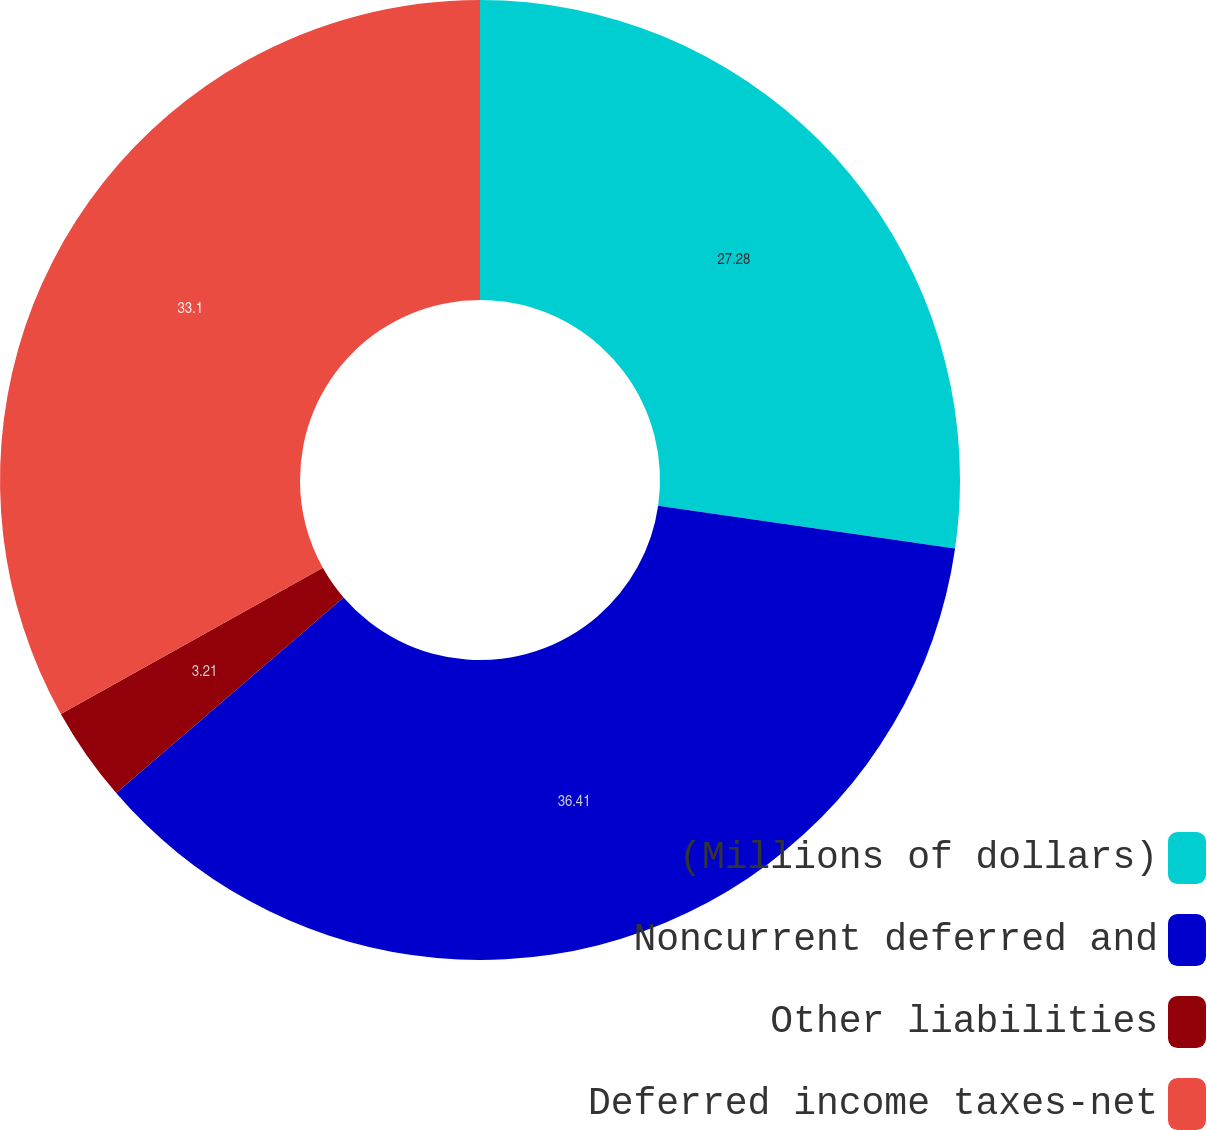<chart> <loc_0><loc_0><loc_500><loc_500><pie_chart><fcel>(Millions of dollars)<fcel>Noncurrent deferred and<fcel>Other liabilities<fcel>Deferred income taxes-net<nl><fcel>27.28%<fcel>36.41%<fcel>3.21%<fcel>33.1%<nl></chart> 